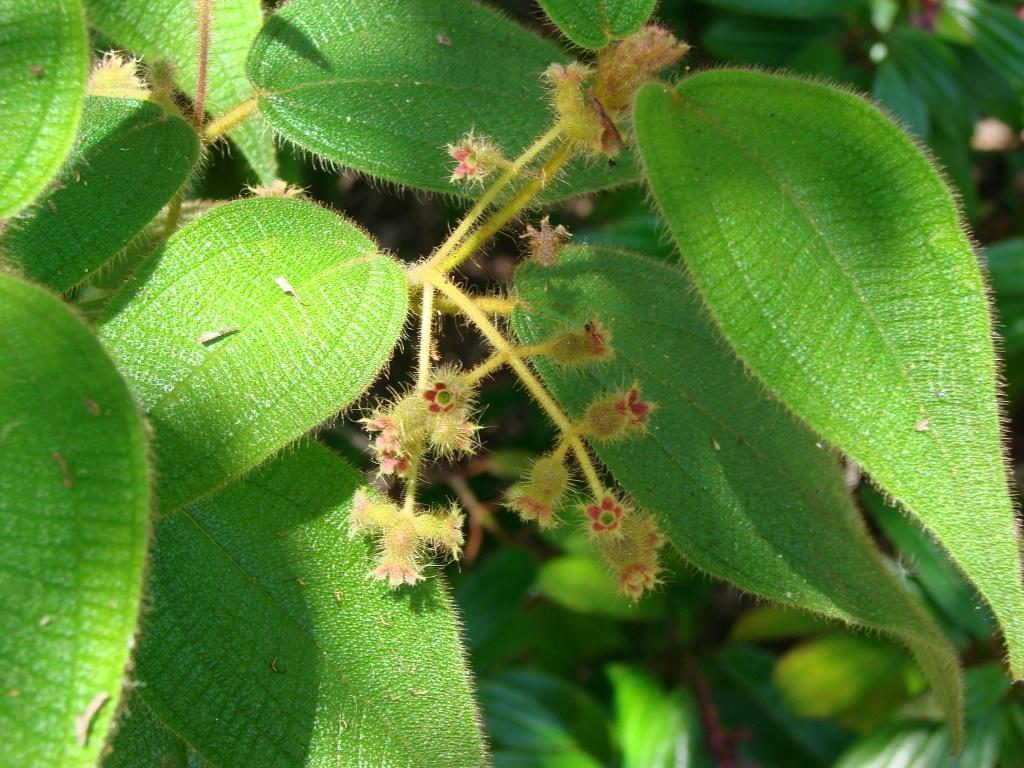In one or two sentences, can you explain what this image depicts? In this image we can see leaves and flowers. 